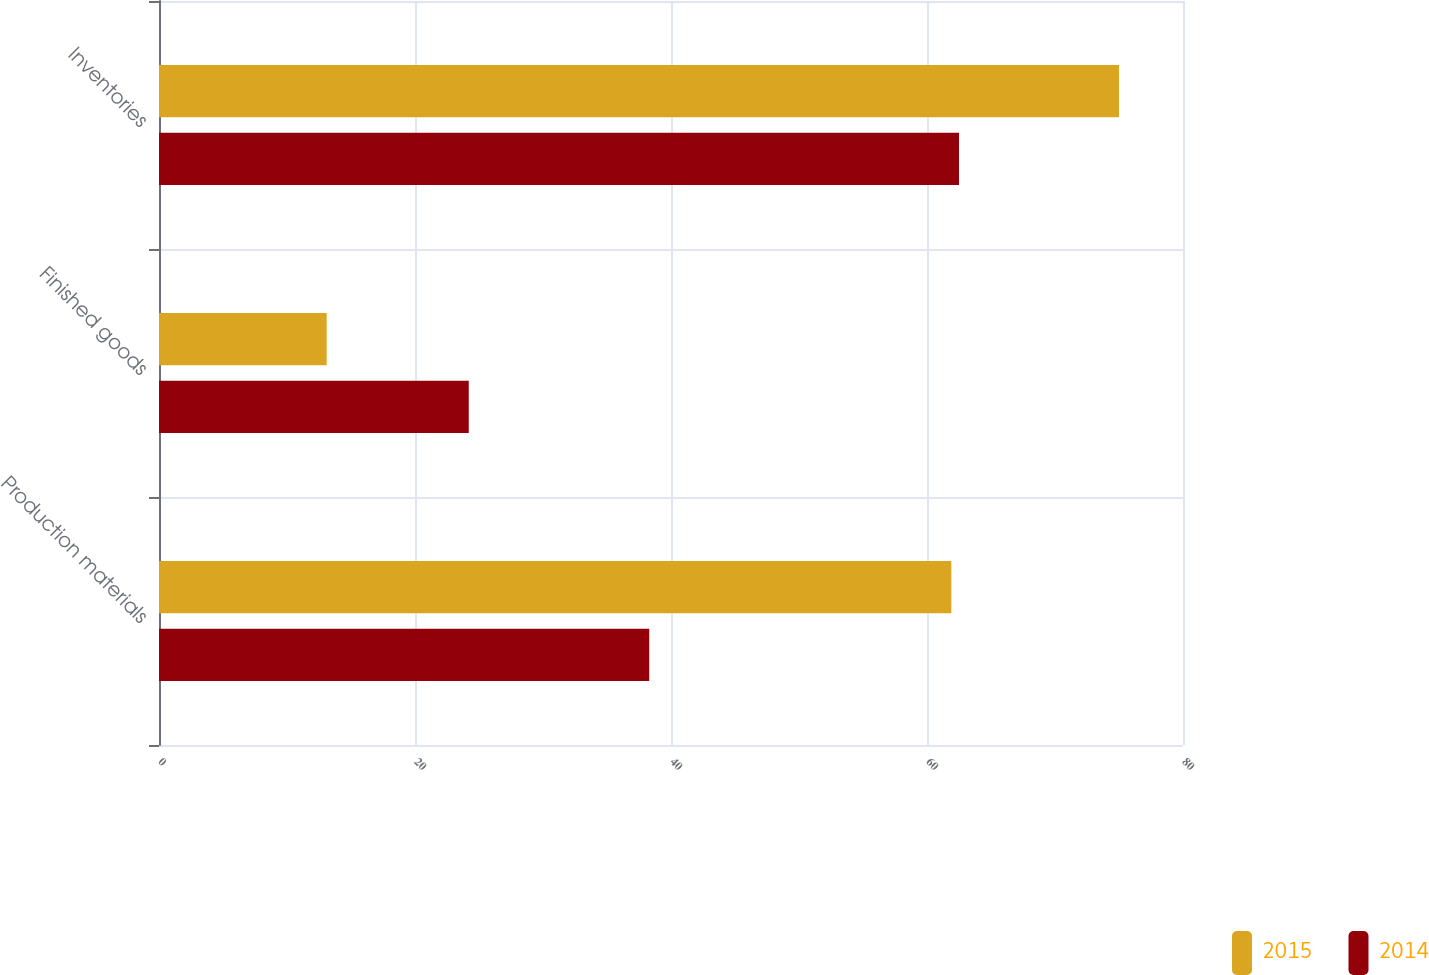<chart> <loc_0><loc_0><loc_500><loc_500><stacked_bar_chart><ecel><fcel>Production materials<fcel>Finished goods<fcel>Inventories<nl><fcel>2015<fcel>61.9<fcel>13.1<fcel>75<nl><fcel>2014<fcel>38.3<fcel>24.2<fcel>62.5<nl></chart> 